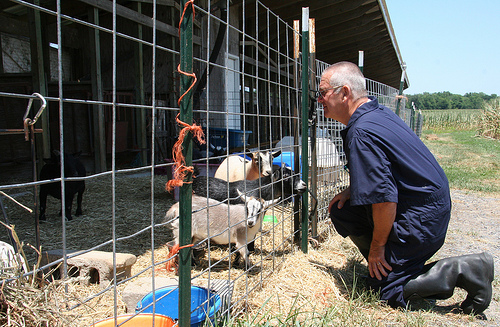<image>
Is the brick on the fence? No. The brick is not positioned on the fence. They may be near each other, but the brick is not supported by or resting on top of the fence. 